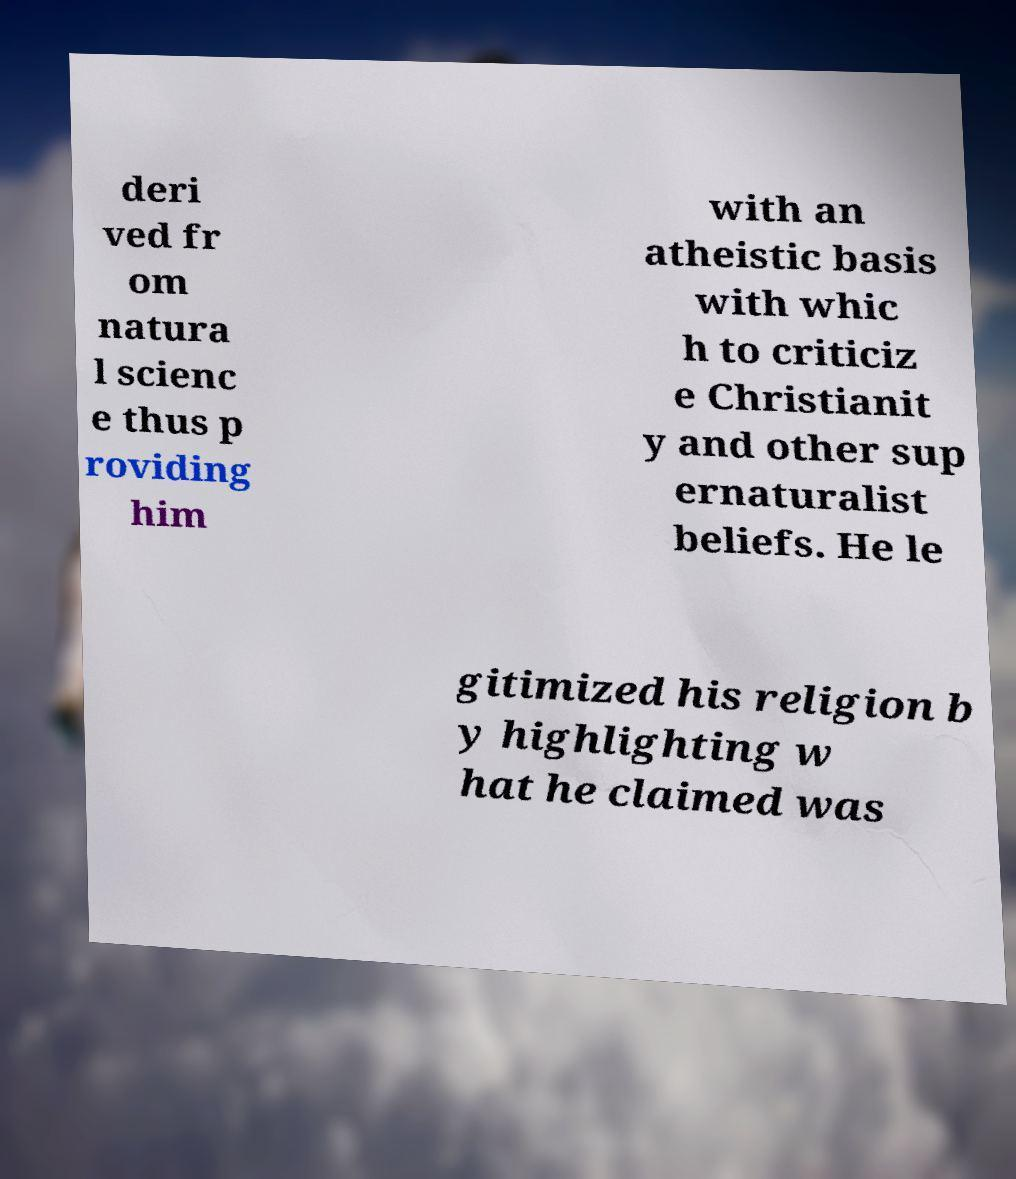For documentation purposes, I need the text within this image transcribed. Could you provide that? deri ved fr om natura l scienc e thus p roviding him with an atheistic basis with whic h to criticiz e Christianit y and other sup ernaturalist beliefs. He le gitimized his religion b y highlighting w hat he claimed was 